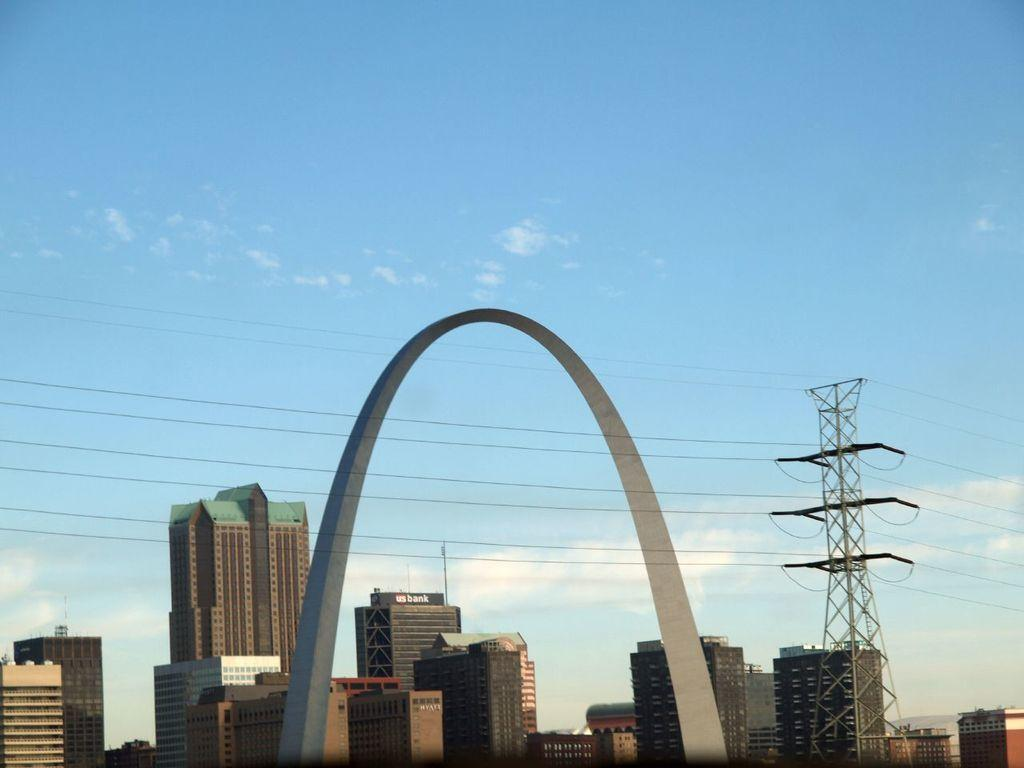What type of structures can be seen in the image? There are buildings in the image. What architectural feature is present in the image? There is an arch in the image. What utility infrastructure is visible in the image? There is an electric pole in the image, and electric wires are visible. What is the color of the sky in the image? The sky is pale blue in the image. Can you see any ants crawling on the electric pole in the image? There are no ants visible in the image, as it focuses on the buildings, arch, electric pole, electric wires, and the pale blue sky. 